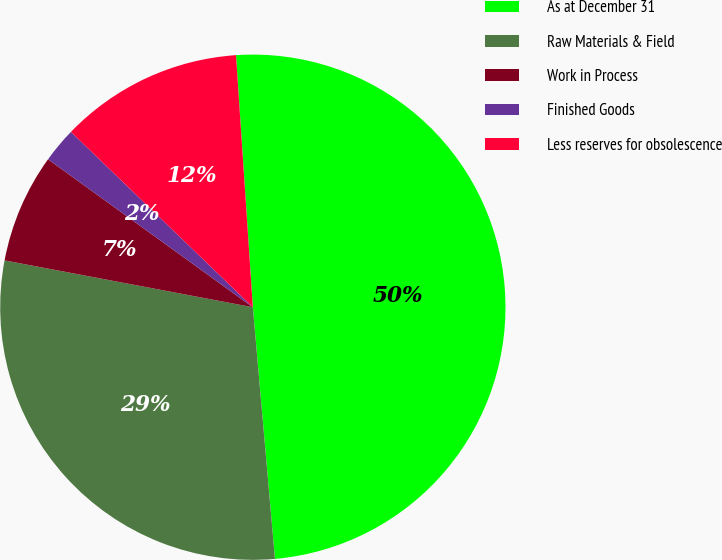Convert chart. <chart><loc_0><loc_0><loc_500><loc_500><pie_chart><fcel>As at December 31<fcel>Raw Materials & Field<fcel>Work in Process<fcel>Finished Goods<fcel>Less reserves for obsolescence<nl><fcel>49.66%<fcel>29.36%<fcel>6.99%<fcel>2.25%<fcel>11.73%<nl></chart> 